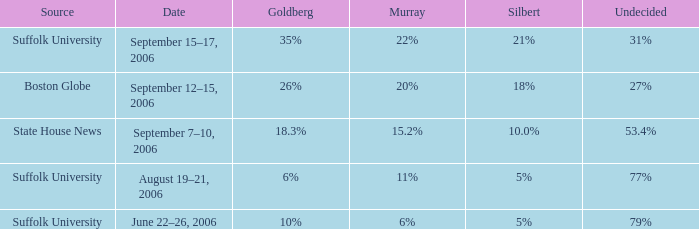What is the percentage of people who haven't made up their minds in the suffolk university poll that shows murray with an 11% support? 77%. 